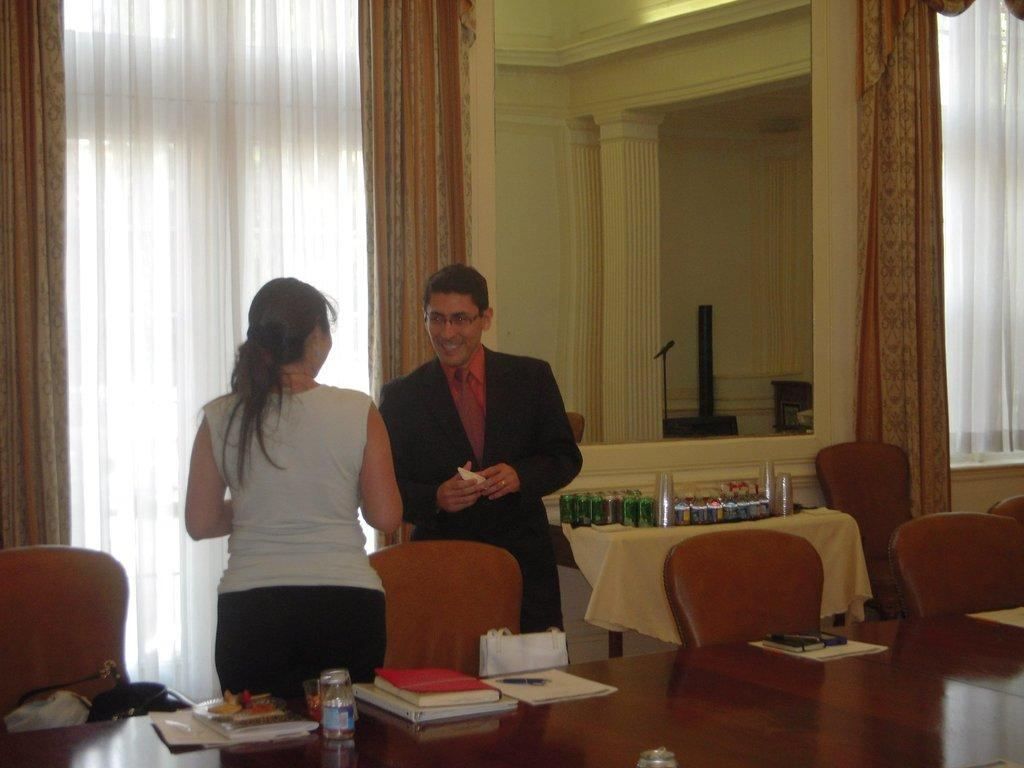What color is the wall in the image? The wall in the image is yellow. What type of window treatment is present in the image? There are curtains in the image. How many people are visible in the image? There are two people standing in the image. What type of furniture is present in the image? There are chairs and tables in the image. What items can be seen on the tables? There are books, pens, and a mobile phone on the tables. What is the title of the book on the table in the image? There is no title visible for the book on the table in the image. What nation are the people in the image from? The facts provided do not give any information about the nationality or origin of the people in the image. Are there any ants visible in the image? There are no ants present in the image. 